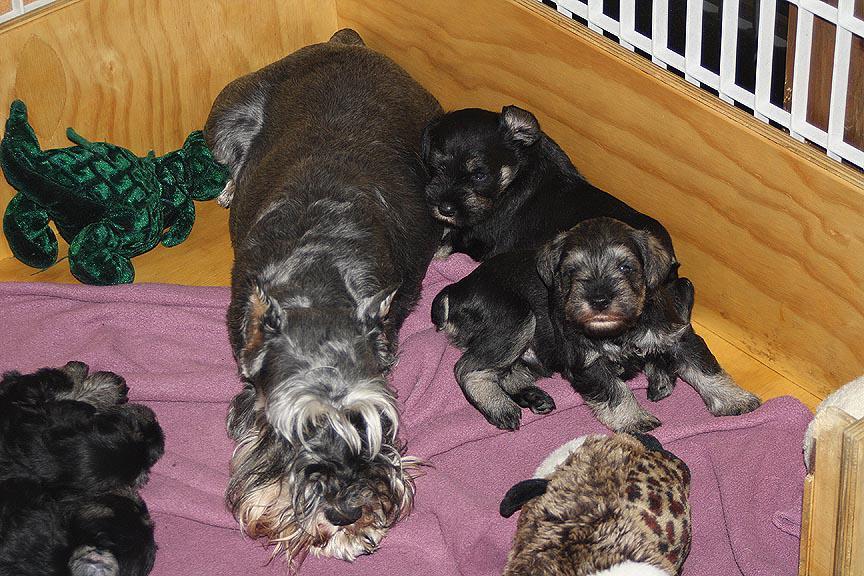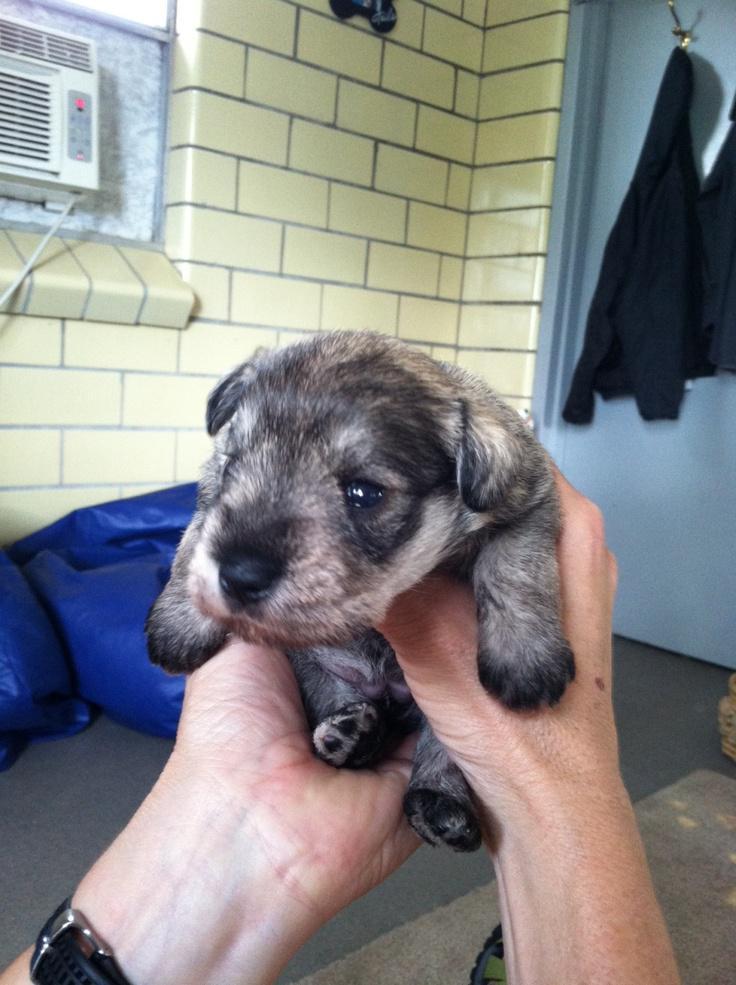The first image is the image on the left, the second image is the image on the right. Assess this claim about the two images: "A human is holding the puppy in the image on the right.". Correct or not? Answer yes or no. Yes. The first image is the image on the left, the second image is the image on the right. Considering the images on both sides, is "There is a single puppy being held in the air in one image." valid? Answer yes or no. Yes. 